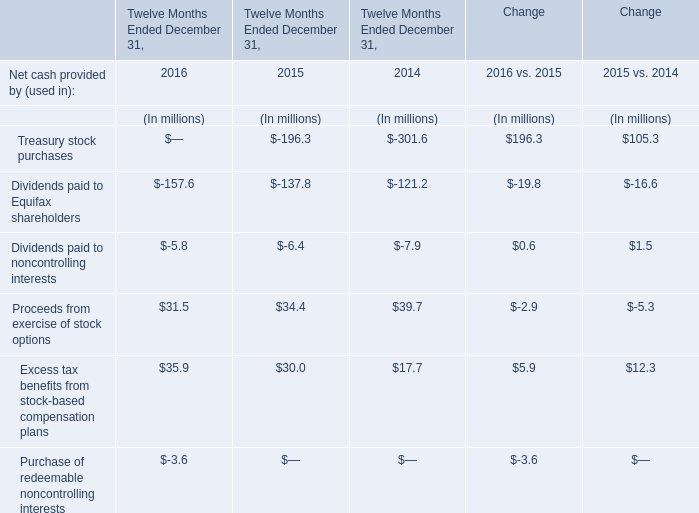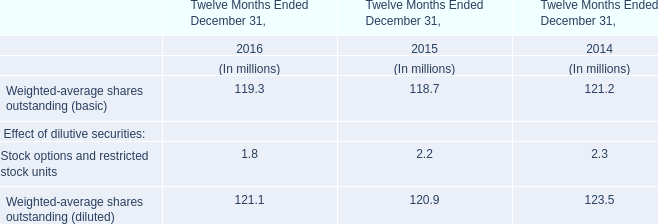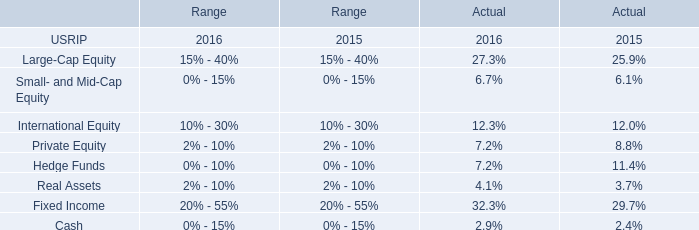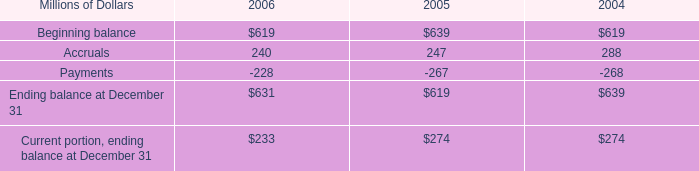what was the percentage change in personal injury liability from 2004 to 2005? 
Computations: ((619 - 639) / 639)
Answer: -0.0313. 